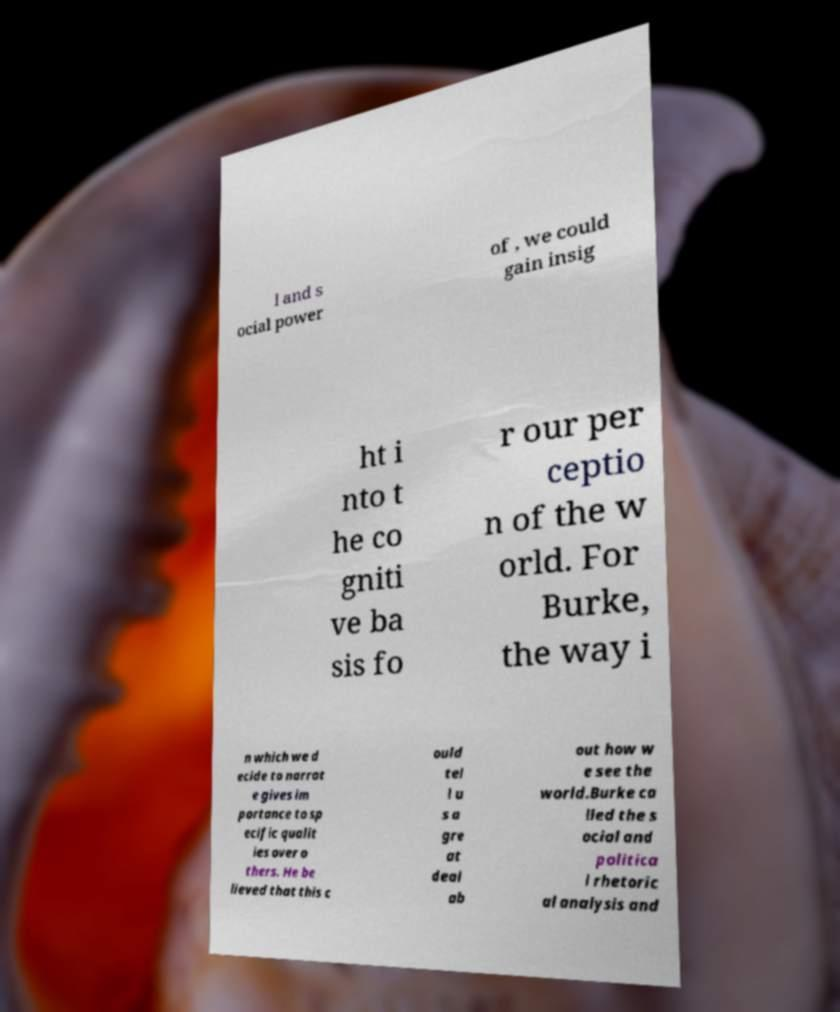Could you extract and type out the text from this image? l and s ocial power of , we could gain insig ht i nto t he co gniti ve ba sis fo r our per ceptio n of the w orld. For Burke, the way i n which we d ecide to narrat e gives im portance to sp ecific qualit ies over o thers. He be lieved that this c ould tel l u s a gre at deal ab out how w e see the world.Burke ca lled the s ocial and politica l rhetoric al analysis and 